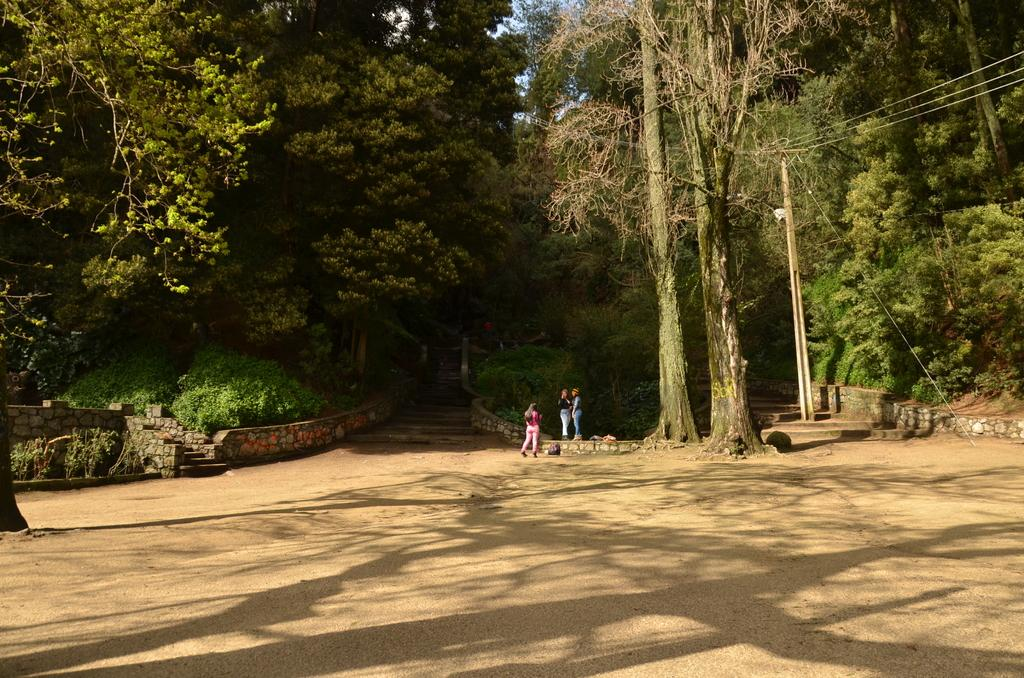How many girls are present in the image? There are three girls in the image. Where are the girls located in the image? The girls are standing in the middle of the image. What can be seen on either side of the girls? There are plants on either side of the girls. What type of vegetation is visible in the image? There are trees visible in the image. What type of blade is being used to cut the record in the image? There is no blade or record present in the image. 